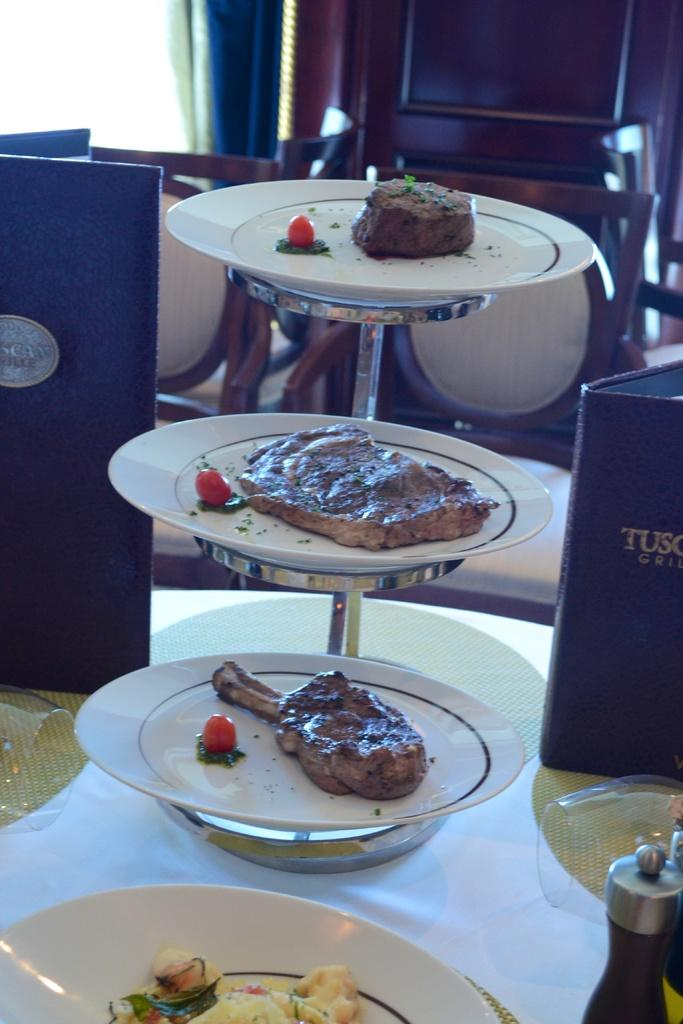What can be seen on the plates in the image? There are plates with food items in the image. What might be used to order food in the image? Menu cards are present in the image. Where are the plates and menu cards located? The plates and menu cards are placed on a table. What can be seen in the background of the image? There are chairs and a curtain in the background of the image. What type of juice can be seen being poured from a dock in the image? There is no dock or juice present in the image. 